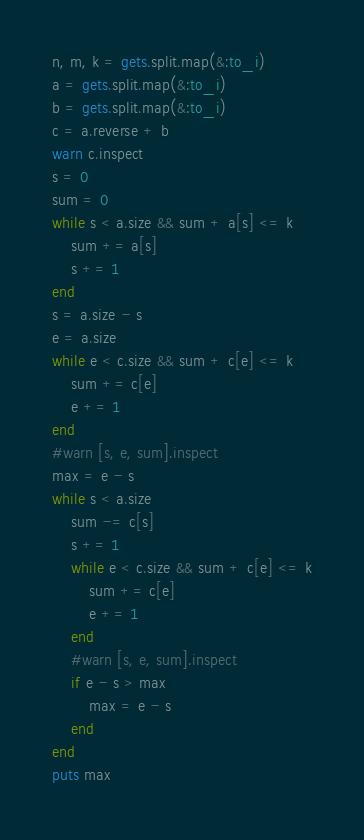Convert code to text. <code><loc_0><loc_0><loc_500><loc_500><_Ruby_>n, m, k = gets.split.map(&:to_i)
a = gets.split.map(&:to_i)
b = gets.split.map(&:to_i)
c = a.reverse + b
warn c.inspect
s = 0
sum = 0
while s < a.size && sum + a[s] <= k
    sum += a[s]
    s += 1
end
s = a.size - s
e = a.size
while e < c.size && sum + c[e] <= k
    sum += c[e]
    e += 1
end
#warn [s, e, sum].inspect
max = e - s
while s < a.size
    sum -= c[s]
    s += 1
    while e < c.size && sum + c[e] <= k
        sum += c[e]
        e += 1
    end
    #warn [s, e, sum].inspect
    if e - s > max
        max = e - s
    end
end
puts max
</code> 